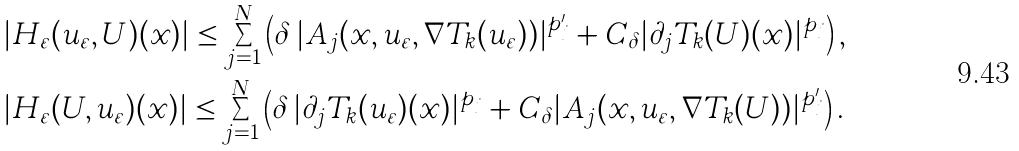<formula> <loc_0><loc_0><loc_500><loc_500>& | H _ { \varepsilon } ( u _ { \varepsilon } , U ) ( x ) | \leq \sum _ { j = 1 } ^ { N } \left ( \delta \, | A _ { j } ( x , u _ { \varepsilon } , \nabla T _ { k } ( u _ { \varepsilon } ) ) | ^ { p _ { j } ^ { \prime } } + C _ { \delta } | \partial _ { j } T _ { k } ( U ) ( x ) | ^ { p _ { j } } \right ) , \\ & | H _ { \varepsilon } ( U , u _ { \varepsilon } ) ( x ) | \leq \sum _ { j = 1 } ^ { N } \left ( \delta \, | \partial _ { j } T _ { k } ( u _ { \varepsilon } ) ( x ) | ^ { p _ { j } } + C _ { \delta } | A _ { j } ( x , u _ { \varepsilon } , \nabla T _ { k } ( U ) ) | ^ { p _ { j } ^ { \prime } } \right ) .</formula> 